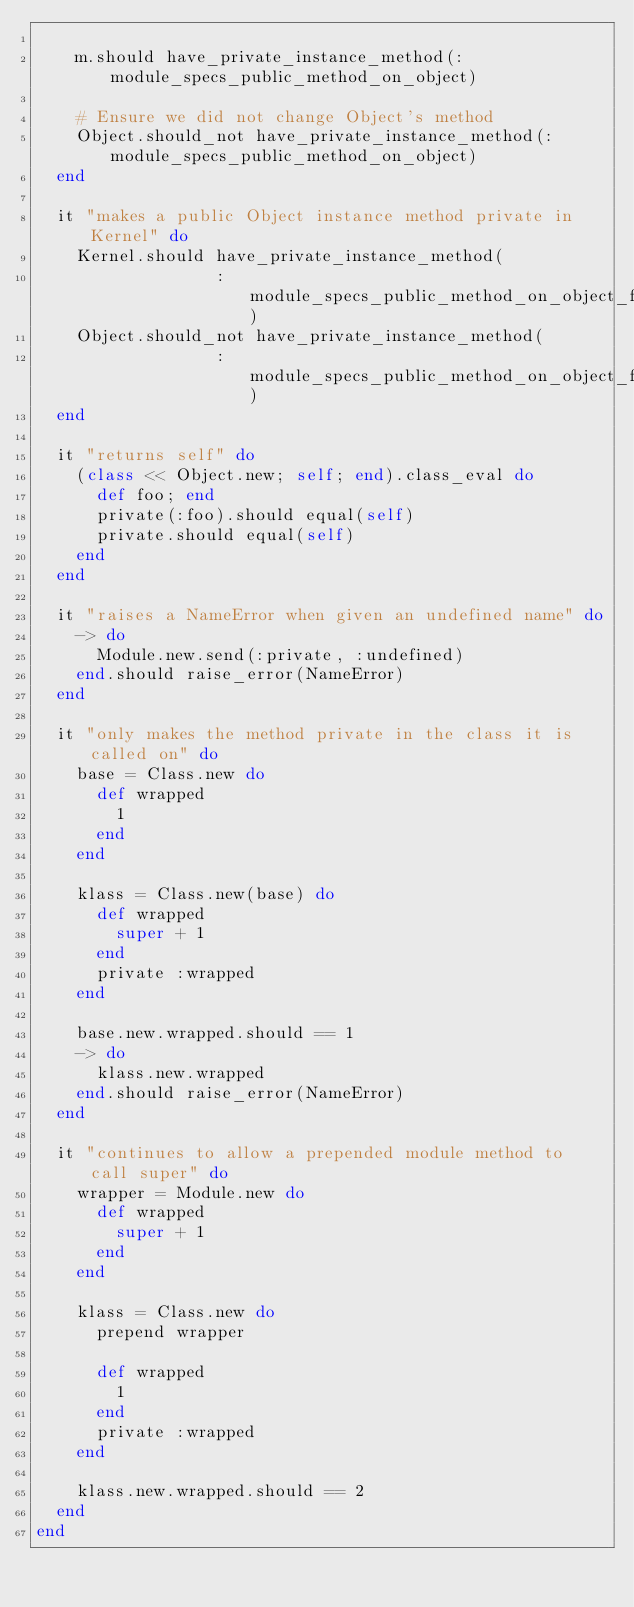<code> <loc_0><loc_0><loc_500><loc_500><_Ruby_>
    m.should have_private_instance_method(:module_specs_public_method_on_object)

    # Ensure we did not change Object's method
    Object.should_not have_private_instance_method(:module_specs_public_method_on_object)
  end

  it "makes a public Object instance method private in Kernel" do
    Kernel.should have_private_instance_method(
                  :module_specs_public_method_on_object_for_kernel_private)
    Object.should_not have_private_instance_method(
                  :module_specs_public_method_on_object_for_kernel_private)
  end

  it "returns self" do
    (class << Object.new; self; end).class_eval do
      def foo; end
      private(:foo).should equal(self)
      private.should equal(self)
    end
  end

  it "raises a NameError when given an undefined name" do
    -> do
      Module.new.send(:private, :undefined)
    end.should raise_error(NameError)
  end

  it "only makes the method private in the class it is called on" do
    base = Class.new do
      def wrapped
        1
      end
    end

    klass = Class.new(base) do
      def wrapped
        super + 1
      end
      private :wrapped
    end

    base.new.wrapped.should == 1
    -> do
      klass.new.wrapped
    end.should raise_error(NameError)
  end

  it "continues to allow a prepended module method to call super" do
    wrapper = Module.new do
      def wrapped
        super + 1
      end
    end

    klass = Class.new do
      prepend wrapper

      def wrapped
        1
      end
      private :wrapped
    end

    klass.new.wrapped.should == 2
  end
end
</code> 